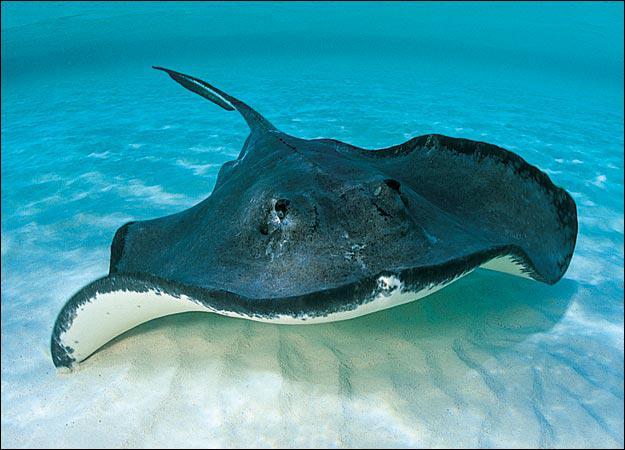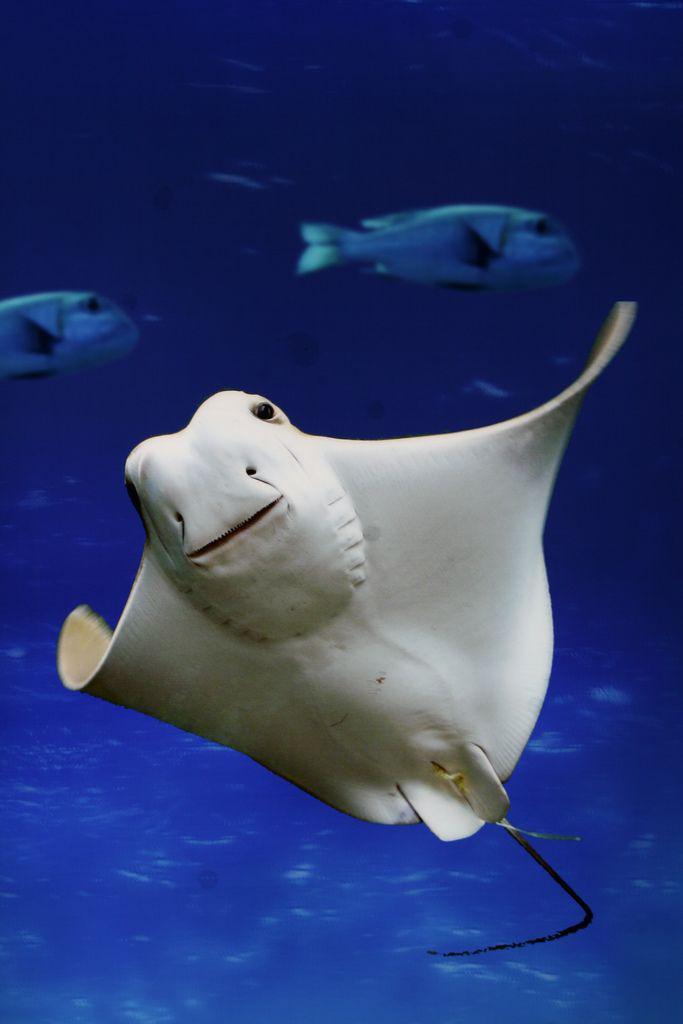The first image is the image on the left, the second image is the image on the right. Evaluate the accuracy of this statement regarding the images: "All images show an upright stingray with wings extended and underside visible.". Is it true? Answer yes or no. No. 